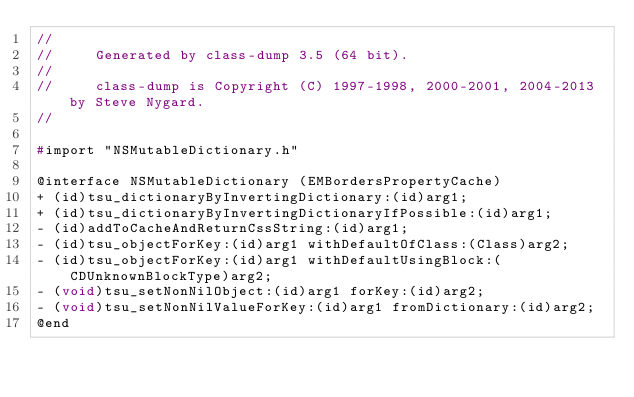Convert code to text. <code><loc_0><loc_0><loc_500><loc_500><_C_>//
//     Generated by class-dump 3.5 (64 bit).
//
//     class-dump is Copyright (C) 1997-1998, 2000-2001, 2004-2013 by Steve Nygard.
//

#import "NSMutableDictionary.h"

@interface NSMutableDictionary (EMBordersPropertyCache)
+ (id)tsu_dictionaryByInvertingDictionary:(id)arg1;
+ (id)tsu_dictionaryByInvertingDictionaryIfPossible:(id)arg1;
- (id)addToCacheAndReturnCssString:(id)arg1;
- (id)tsu_objectForKey:(id)arg1 withDefaultOfClass:(Class)arg2;
- (id)tsu_objectForKey:(id)arg1 withDefaultUsingBlock:(CDUnknownBlockType)arg2;
- (void)tsu_setNonNilObject:(id)arg1 forKey:(id)arg2;
- (void)tsu_setNonNilValueForKey:(id)arg1 fromDictionary:(id)arg2;
@end

</code> 